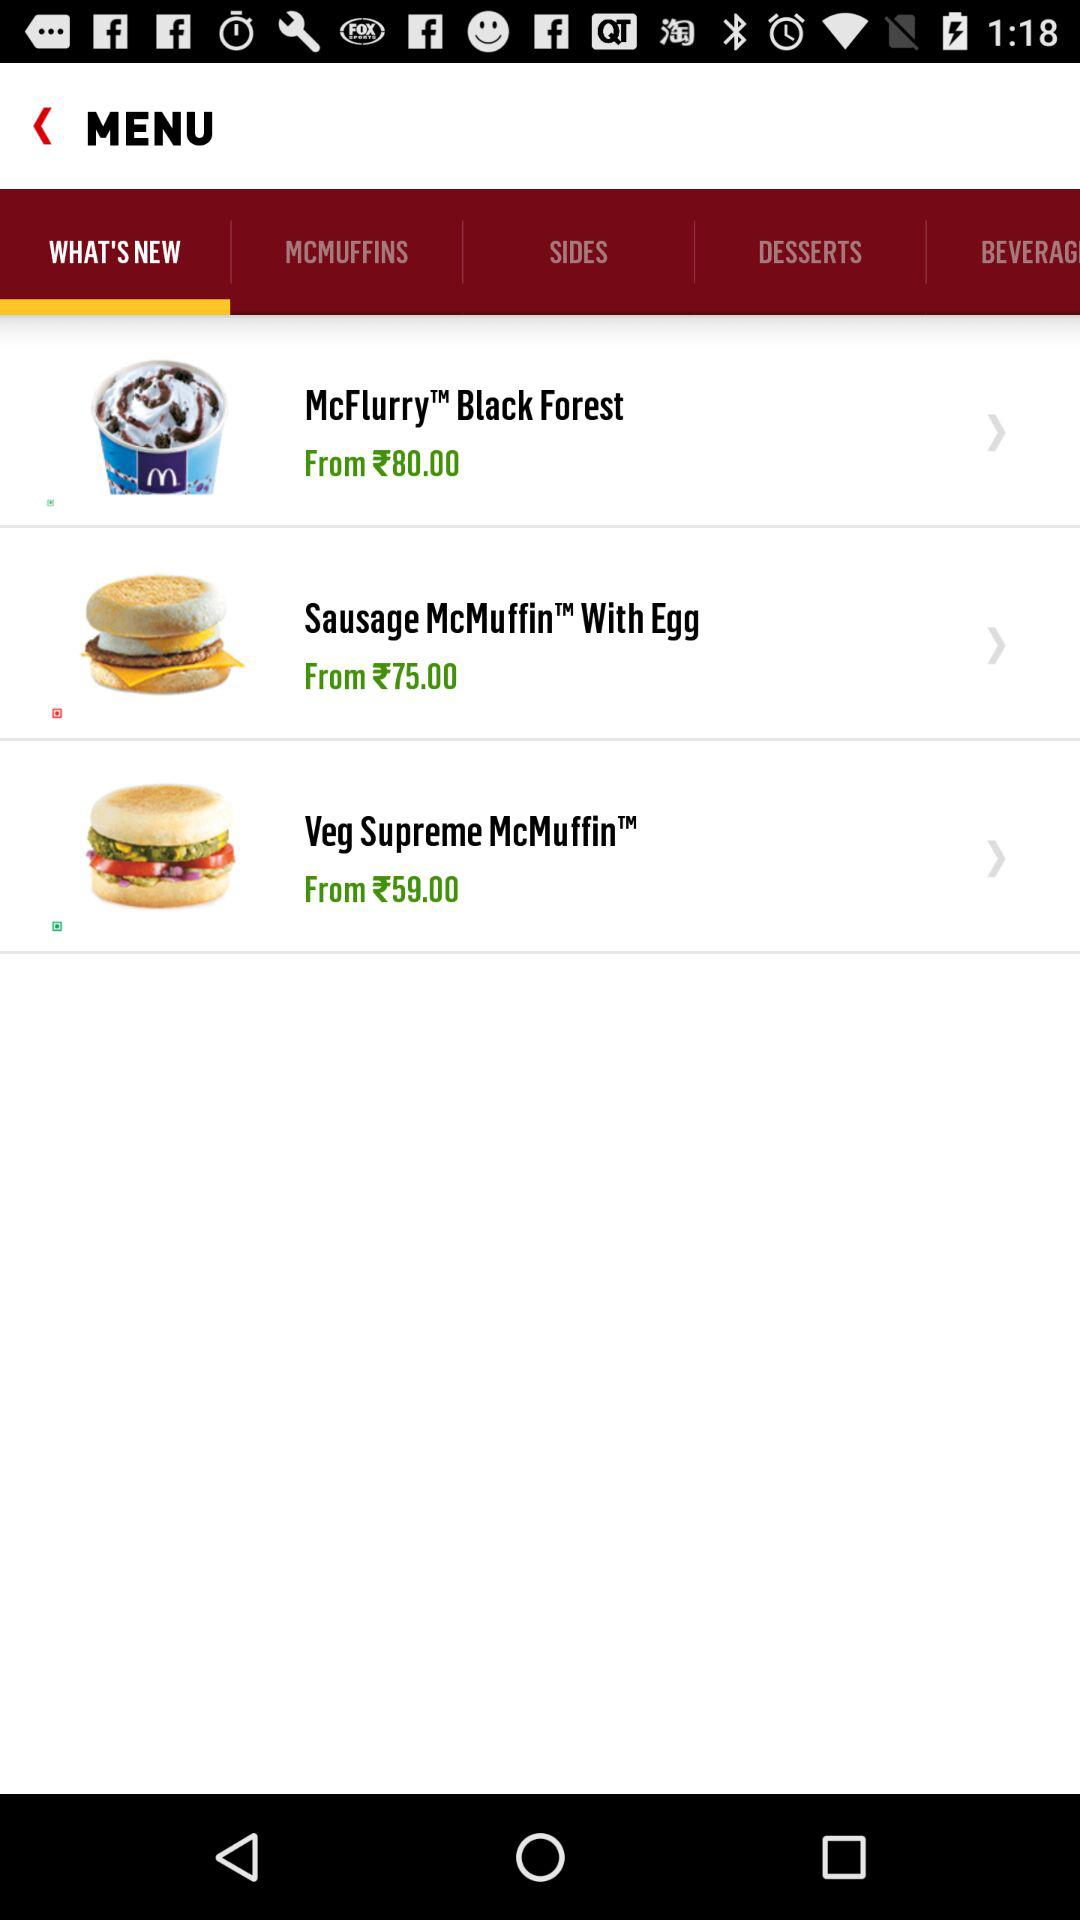What is the selected tab? The selected tab is "WHAT'S NEW". 